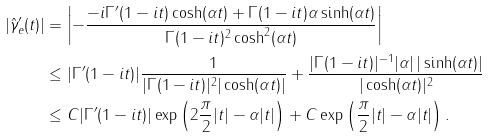<formula> <loc_0><loc_0><loc_500><loc_500>| \hat { \gamma } _ { e } ^ { \prime } ( t ) | & = \left | - \frac { - i \Gamma ^ { \prime } ( 1 - i t ) \cosh ( \alpha t ) + \Gamma ( 1 - i t ) \alpha \sinh ( \alpha t ) } { \Gamma ( 1 - i t ) ^ { 2 } \cosh ^ { 2 } ( \alpha t ) } \right | \\ & \leq | \Gamma ^ { \prime } ( 1 - i t ) | \frac { 1 } { | \Gamma ( 1 - i t ) | ^ { 2 } | \cosh ( \alpha t ) | } + \frac { | \Gamma ( 1 - i t ) | ^ { - 1 } | \alpha | \, | \sinh ( \alpha t ) | } { | \cosh ( \alpha t ) | ^ { 2 } } \\ & \leq C | \Gamma ^ { \prime } ( 1 - i t ) | \exp \left ( 2 \frac { \pi } { 2 } | t | - \alpha | t | \right ) + C \exp \left ( \frac { \pi } { 2 } | t | - \alpha | t | \right ) .</formula> 